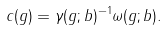<formula> <loc_0><loc_0><loc_500><loc_500>c ( g ) = \gamma ( g ; b ) ^ { - 1 } \omega ( g ; b ) .</formula> 